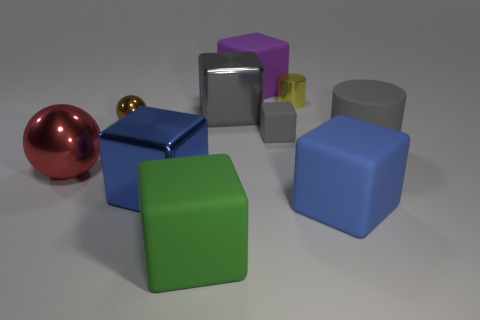Subtract all big gray cubes. How many cubes are left? 5 Subtract 1 spheres. How many spheres are left? 1 Subtract all small rubber blocks. Subtract all large cylinders. How many objects are left? 8 Add 9 red shiny things. How many red shiny things are left? 10 Add 8 large red metal balls. How many large red metal balls exist? 9 Subtract all gray cylinders. How many cylinders are left? 1 Subtract 0 green spheres. How many objects are left? 10 Subtract all balls. How many objects are left? 8 Subtract all cyan balls. Subtract all purple cylinders. How many balls are left? 2 Subtract all red balls. How many gray cylinders are left? 1 